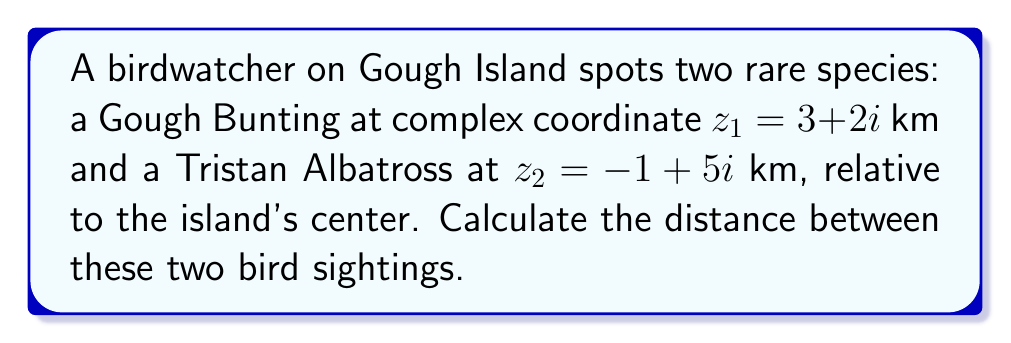Give your solution to this math problem. To find the distance between two points in the complex plane, we can use the absolute value of the difference between the two complex numbers.

1) Let's define the difference between the two points:
   $\Delta z = z_2 - z_1 = (-1 + 5i) - (3 + 2i)$

2) Simplify:
   $\Delta z = -1 + 5i - 3 - 2i = -4 + 3i$

3) The distance is the absolute value (magnitude) of this difference:
   $d = |\Delta z| = |-4 + 3i|$

4) For a complex number $a + bi$, the absolute value is given by $\sqrt{a^2 + b^2}$:
   $d = \sqrt{(-4)^2 + 3^2}$

5) Simplify:
   $d = \sqrt{16 + 9} = \sqrt{25} = 5$

Therefore, the distance between the two bird sightings is 5 km.
Answer: $5$ km 